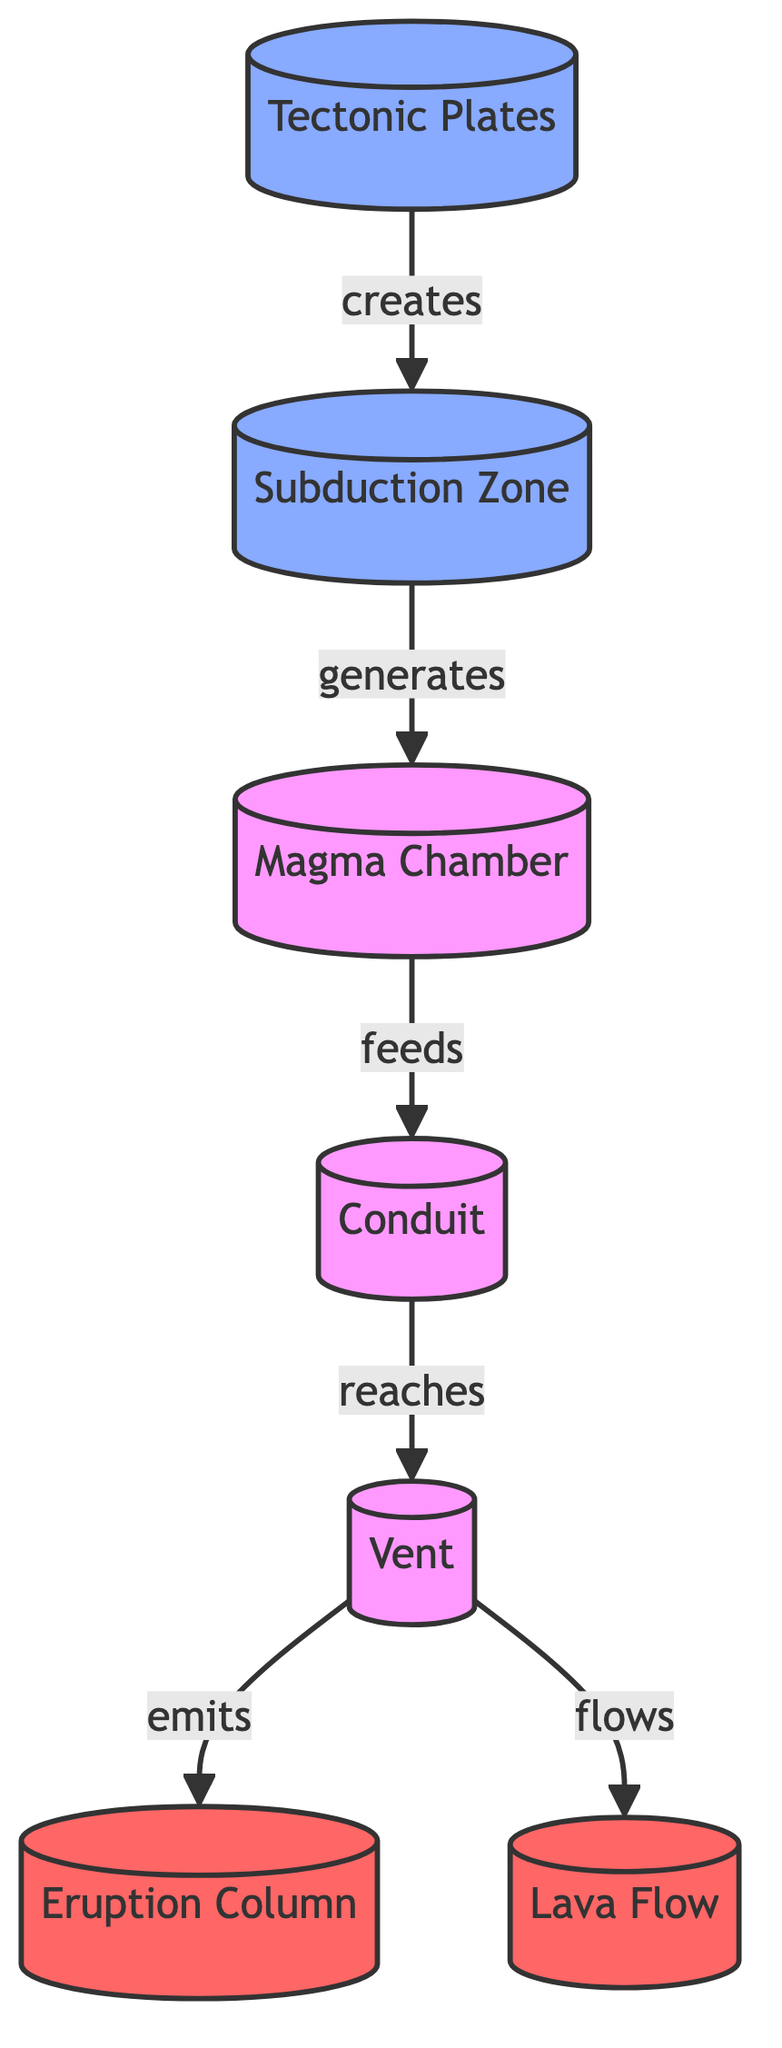What are the main components involved in a volcanic eruption as depicted in the diagram? The diagram includes the following main components: Tectonic Plates, Subduction Zone, Magma Chamber, Conduit, Vent, Eruption Column, and Lava Flow.
Answer: Tectonic Plates, Subduction Zone, Magma Chamber, Conduit, Vent, Eruption Column, Lava Flow How many directional relationships are shown in the diagram? The diagram displays six directional relationships: Tectonic Plates to Subduction Zone, Subduction Zone to Magma Chamber, Magma Chamber to Conduit, Conduit to Vent, Vent to Eruption Column, and Vent to Lava Flow, making a total of six.
Answer: 6 What flows directly from the Vent after magma reaches it? The diagram shows that upon reaching the Vent, magma can either emit as an Eruption Column or flow as Lava Flow. Thus, both Eruption Column and Lava Flow are correct responses.
Answer: Eruption Column, Lava Flow What generates the Magma Chamber according to the diagram? The relationship in the diagram indicates that the Subduction Zone generates the Magma Chamber. So, by tracing the arrow from Subduction Zone to Magma Chamber, we establish the connection.
Answer: Subduction Zone Which component is the last step before magma is emitted into the atmosphere? By following the flow in the diagram, the last step before magma is emitted into the atmosphere occurs at the Vent. The arrows indicate that the Vent leads to the Eruption Column.
Answer: Vent What is the primary source that creates the Subduction Zone? The diagram shows an arrow pointing from Tectonic Plates to Subduction Zone, indicating that Tectonic Plates are responsible for creating the Subduction Zone.
Answer: Tectonic Plates Which two outcomes are linked to the Vent in the eruption process? As shown in the diagram, the two outcomes linked to the Vent are the Eruption Column (emission into the atmosphere) and Lava Flow (flow outwards). Therefore, both outcomes stem from the same component (Vent).
Answer: Eruption Column, Lava Flow 